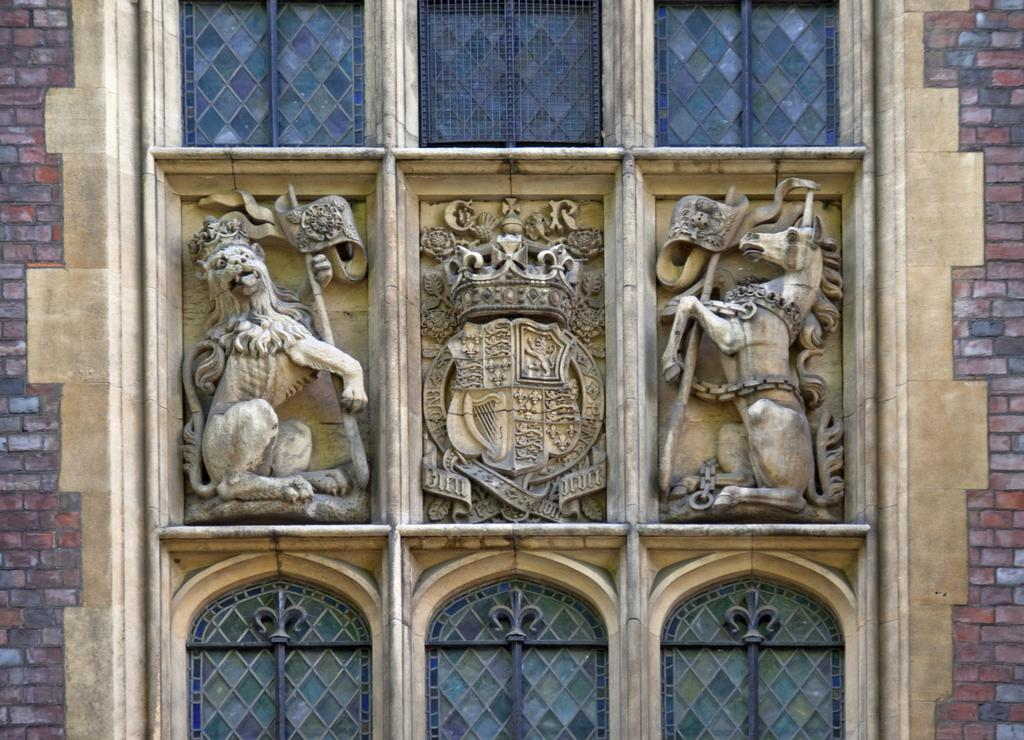What type of decorations are on the wall in the image? There are animal sculptures on the wall in the image. What else can be seen on the wall besides the animal sculptures? The wall has windows. What are the animal sculptures holding in the image? The animal sculptures are holding flags. What type of feast is being prepared on the ground in the image? There is no feast or ground present in the image; it only features animal sculptures holding flags on a wall with windows. 